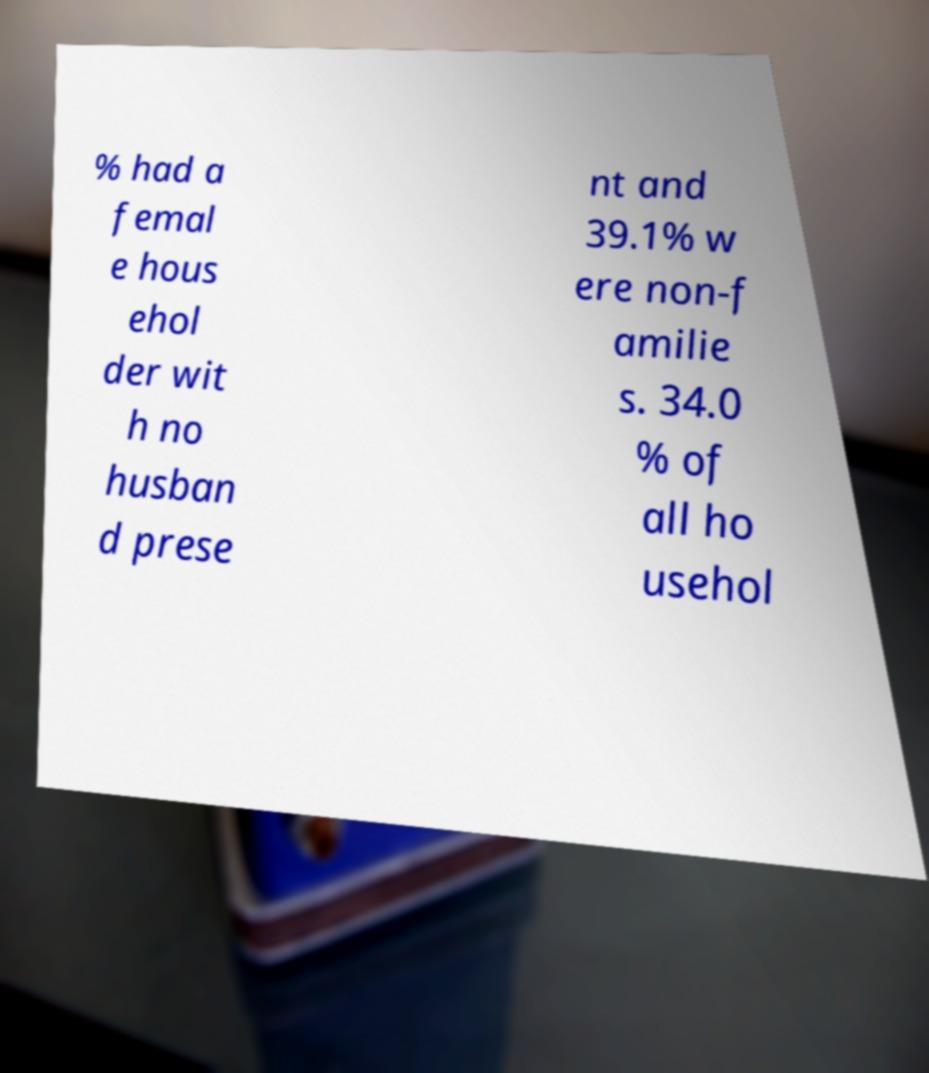Could you extract and type out the text from this image? % had a femal e hous ehol der wit h no husban d prese nt and 39.1% w ere non-f amilie s. 34.0 % of all ho usehol 